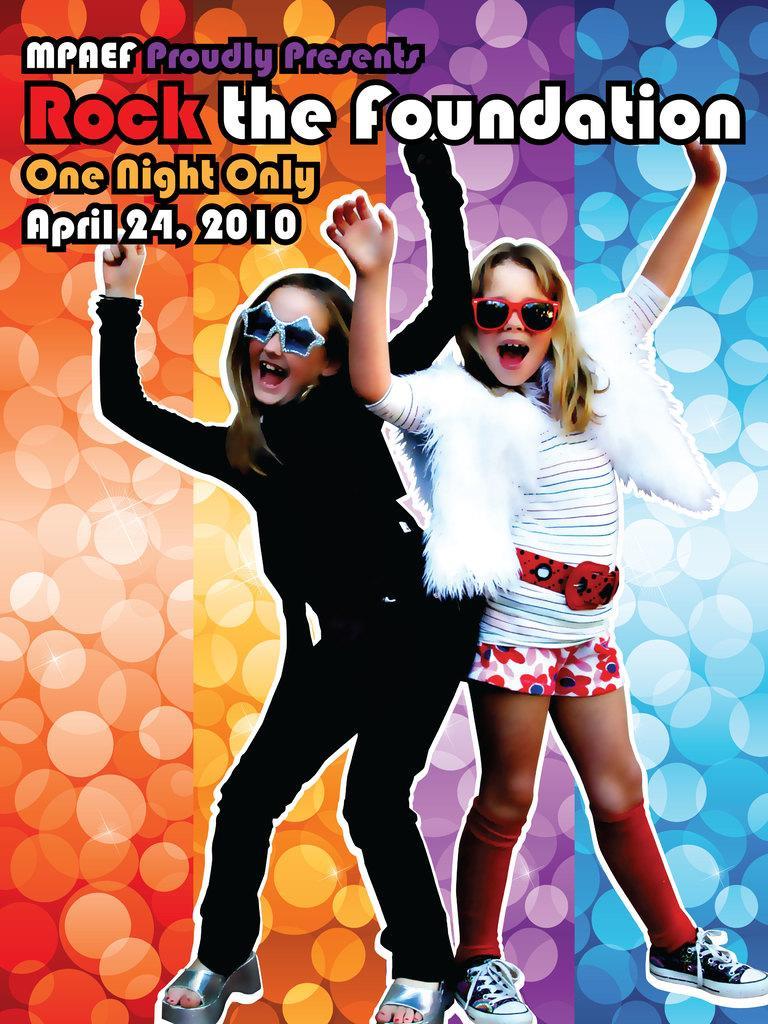Could you give a brief overview of what you see in this image? In this image we can see a poster. There are few people in the image. There is some text at the top of the image. 